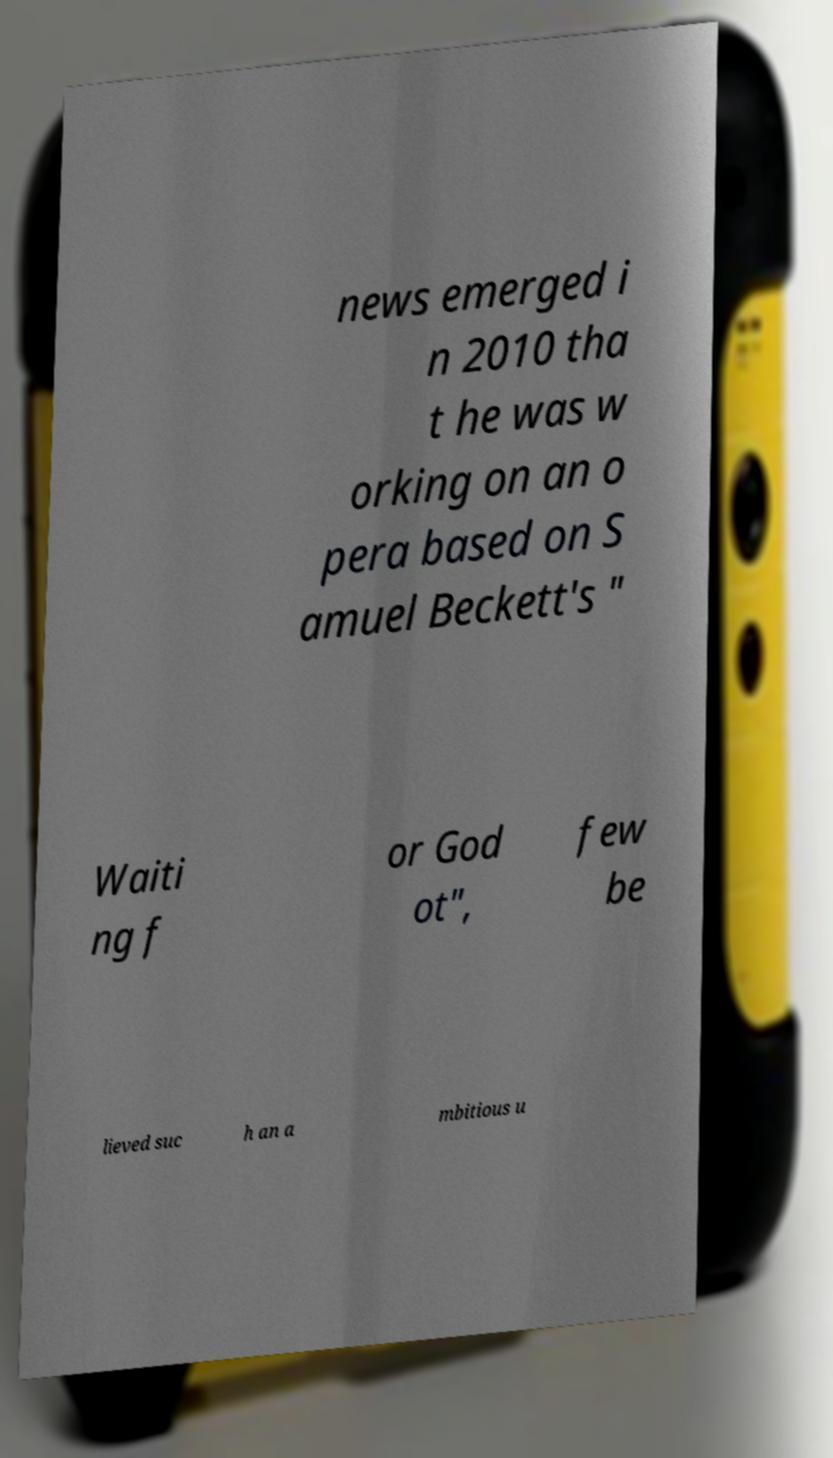Can you accurately transcribe the text from the provided image for me? news emerged i n 2010 tha t he was w orking on an o pera based on S amuel Beckett's " Waiti ng f or God ot", few be lieved suc h an a mbitious u 